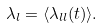<formula> <loc_0><loc_0><loc_500><loc_500>\lambda _ { l } = \langle \lambda _ { l l } ( t ) \rangle .</formula> 